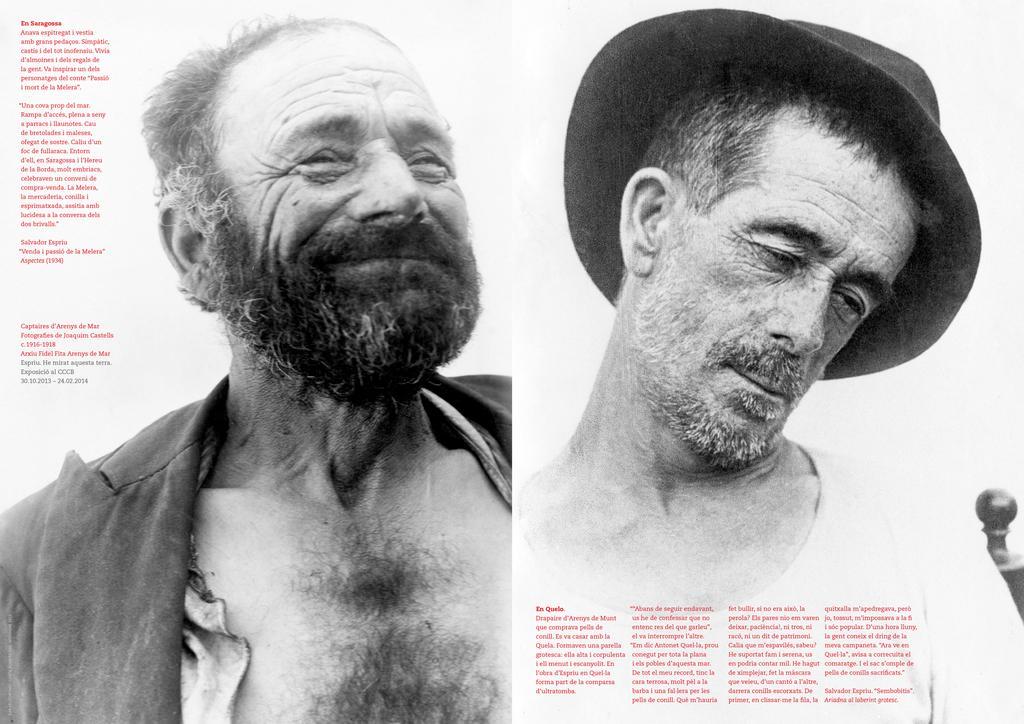Could you give a brief overview of what you see in this image? This image contains a poster having pictures of two persons and some text. Right side there is a person wearing a cap. 